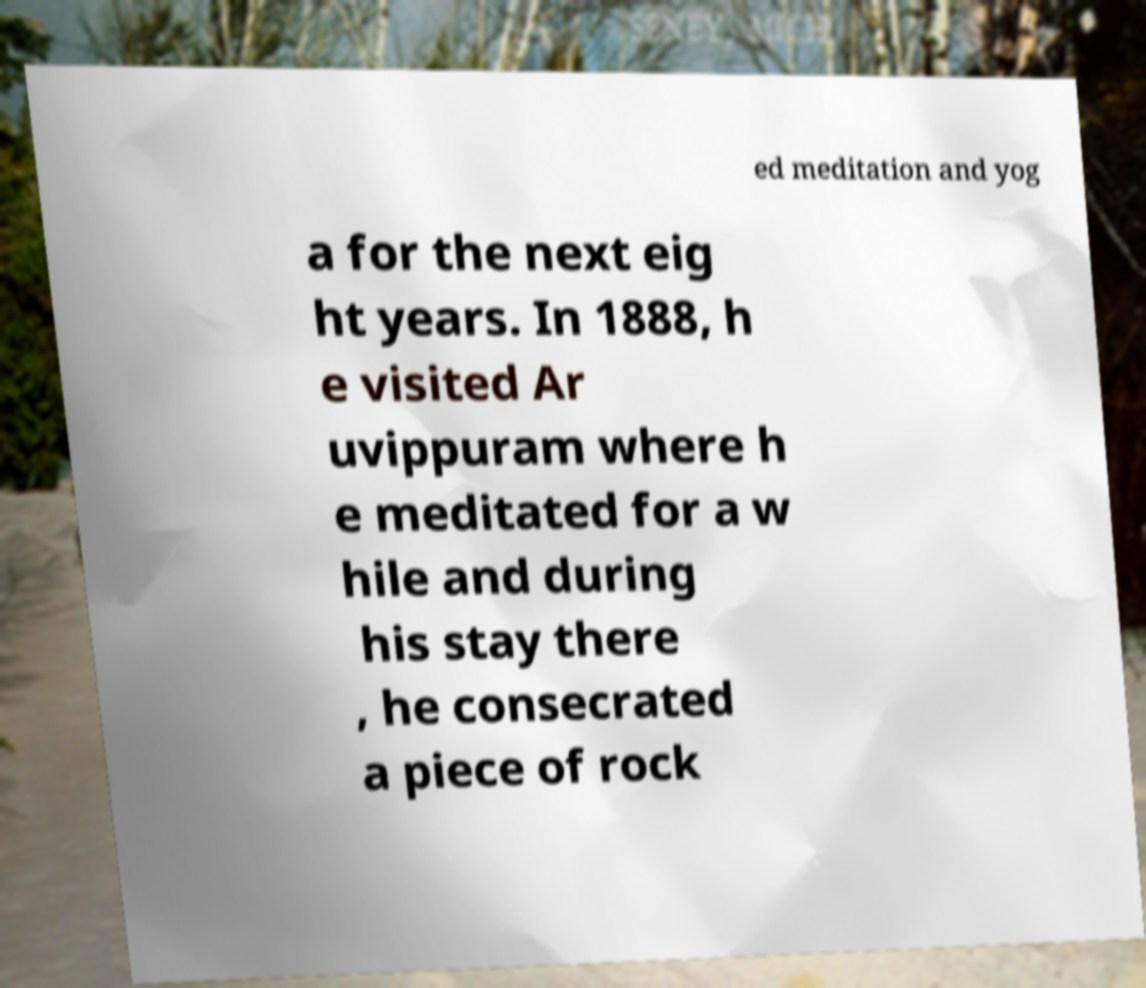Can you read and provide the text displayed in the image?This photo seems to have some interesting text. Can you extract and type it out for me? ed meditation and yog a for the next eig ht years. In 1888, h e visited Ar uvippuram where h e meditated for a w hile and during his stay there , he consecrated a piece of rock 